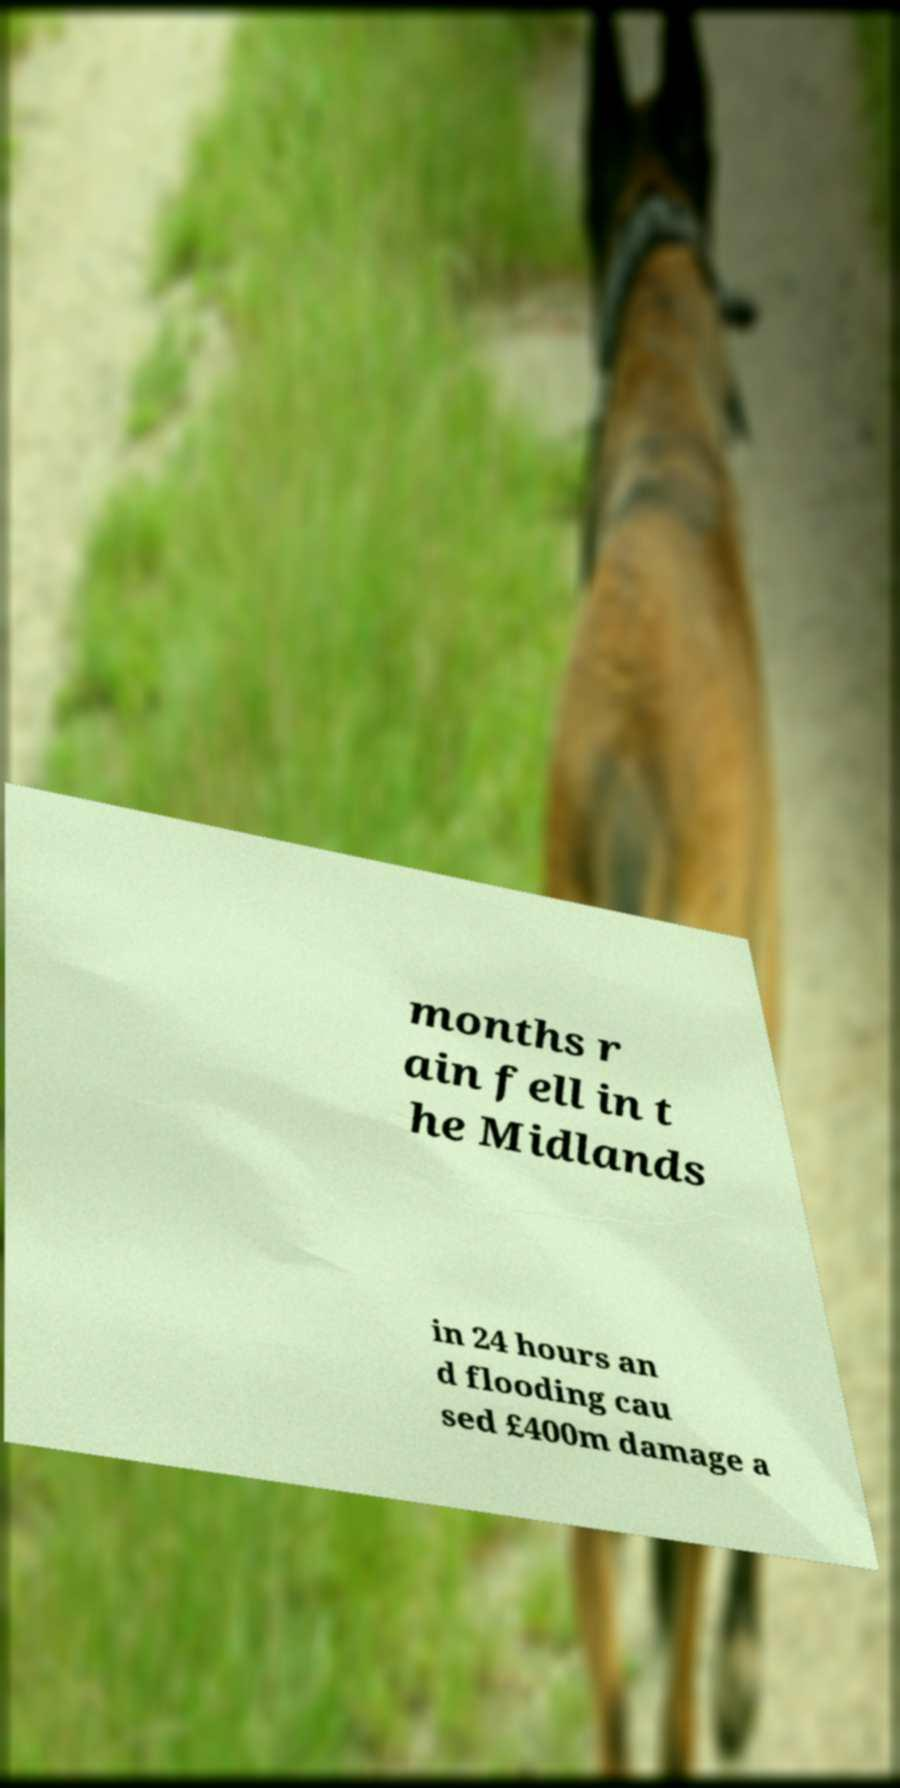Could you assist in decoding the text presented in this image and type it out clearly? months r ain fell in t he Midlands in 24 hours an d flooding cau sed £400m damage a 